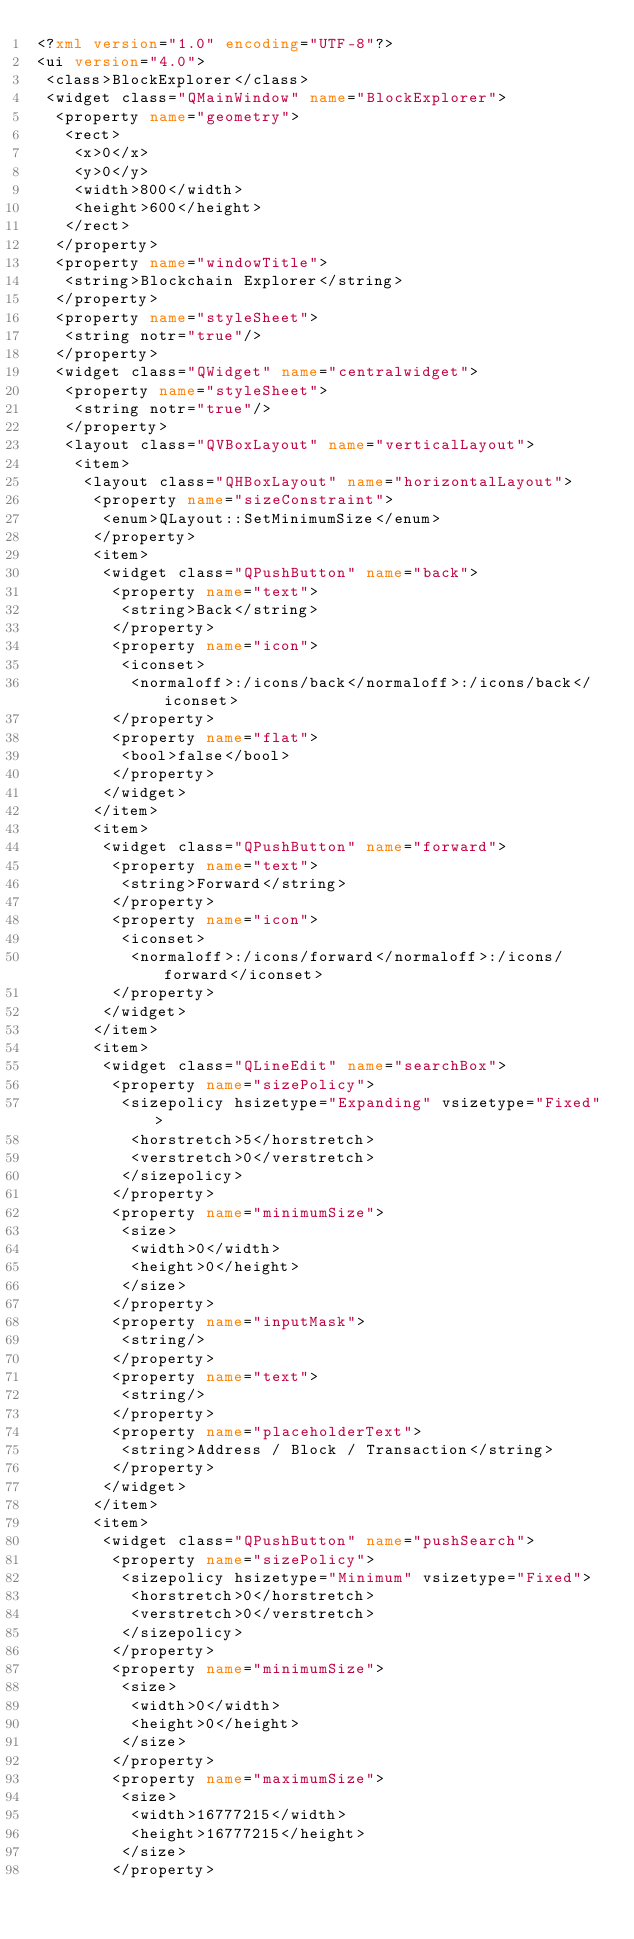<code> <loc_0><loc_0><loc_500><loc_500><_XML_><?xml version="1.0" encoding="UTF-8"?>
<ui version="4.0">
 <class>BlockExplorer</class>
 <widget class="QMainWindow" name="BlockExplorer">
  <property name="geometry">
   <rect>
    <x>0</x>
    <y>0</y>
    <width>800</width>
    <height>600</height>
   </rect>
  </property>
  <property name="windowTitle">
   <string>Blockchain Explorer</string>
  </property>
  <property name="styleSheet">
   <string notr="true"/>
  </property>
  <widget class="QWidget" name="centralwidget">
   <property name="styleSheet">
    <string notr="true"/>
   </property>
   <layout class="QVBoxLayout" name="verticalLayout">
    <item>
     <layout class="QHBoxLayout" name="horizontalLayout">
      <property name="sizeConstraint">
       <enum>QLayout::SetMinimumSize</enum>
      </property>
      <item>
       <widget class="QPushButton" name="back">
        <property name="text">
         <string>Back</string>
        </property>
        <property name="icon">
         <iconset>
          <normaloff>:/icons/back</normaloff>:/icons/back</iconset>
        </property>
        <property name="flat">
         <bool>false</bool>
        </property>
       </widget>
      </item>
      <item>
       <widget class="QPushButton" name="forward">
        <property name="text">
         <string>Forward</string>
        </property>
        <property name="icon">
         <iconset>
          <normaloff>:/icons/forward</normaloff>:/icons/forward</iconset>
        </property>
       </widget>
      </item>
      <item>
       <widget class="QLineEdit" name="searchBox">
        <property name="sizePolicy">
         <sizepolicy hsizetype="Expanding" vsizetype="Fixed">
          <horstretch>5</horstretch>
          <verstretch>0</verstretch>
         </sizepolicy>
        </property>
        <property name="minimumSize">
         <size>
          <width>0</width>
          <height>0</height>
         </size>
        </property>
        <property name="inputMask">
         <string/>
        </property>
        <property name="text">
         <string/>
        </property>
        <property name="placeholderText">
         <string>Address / Block / Transaction</string>
        </property>
       </widget>
      </item>
      <item>
       <widget class="QPushButton" name="pushSearch">
        <property name="sizePolicy">
         <sizepolicy hsizetype="Minimum" vsizetype="Fixed">
          <horstretch>0</horstretch>
          <verstretch>0</verstretch>
         </sizepolicy>
        </property>
        <property name="minimumSize">
         <size>
          <width>0</width>
          <height>0</height>
         </size>
        </property>
        <property name="maximumSize">
         <size>
          <width>16777215</width>
          <height>16777215</height>
         </size>
        </property></code> 